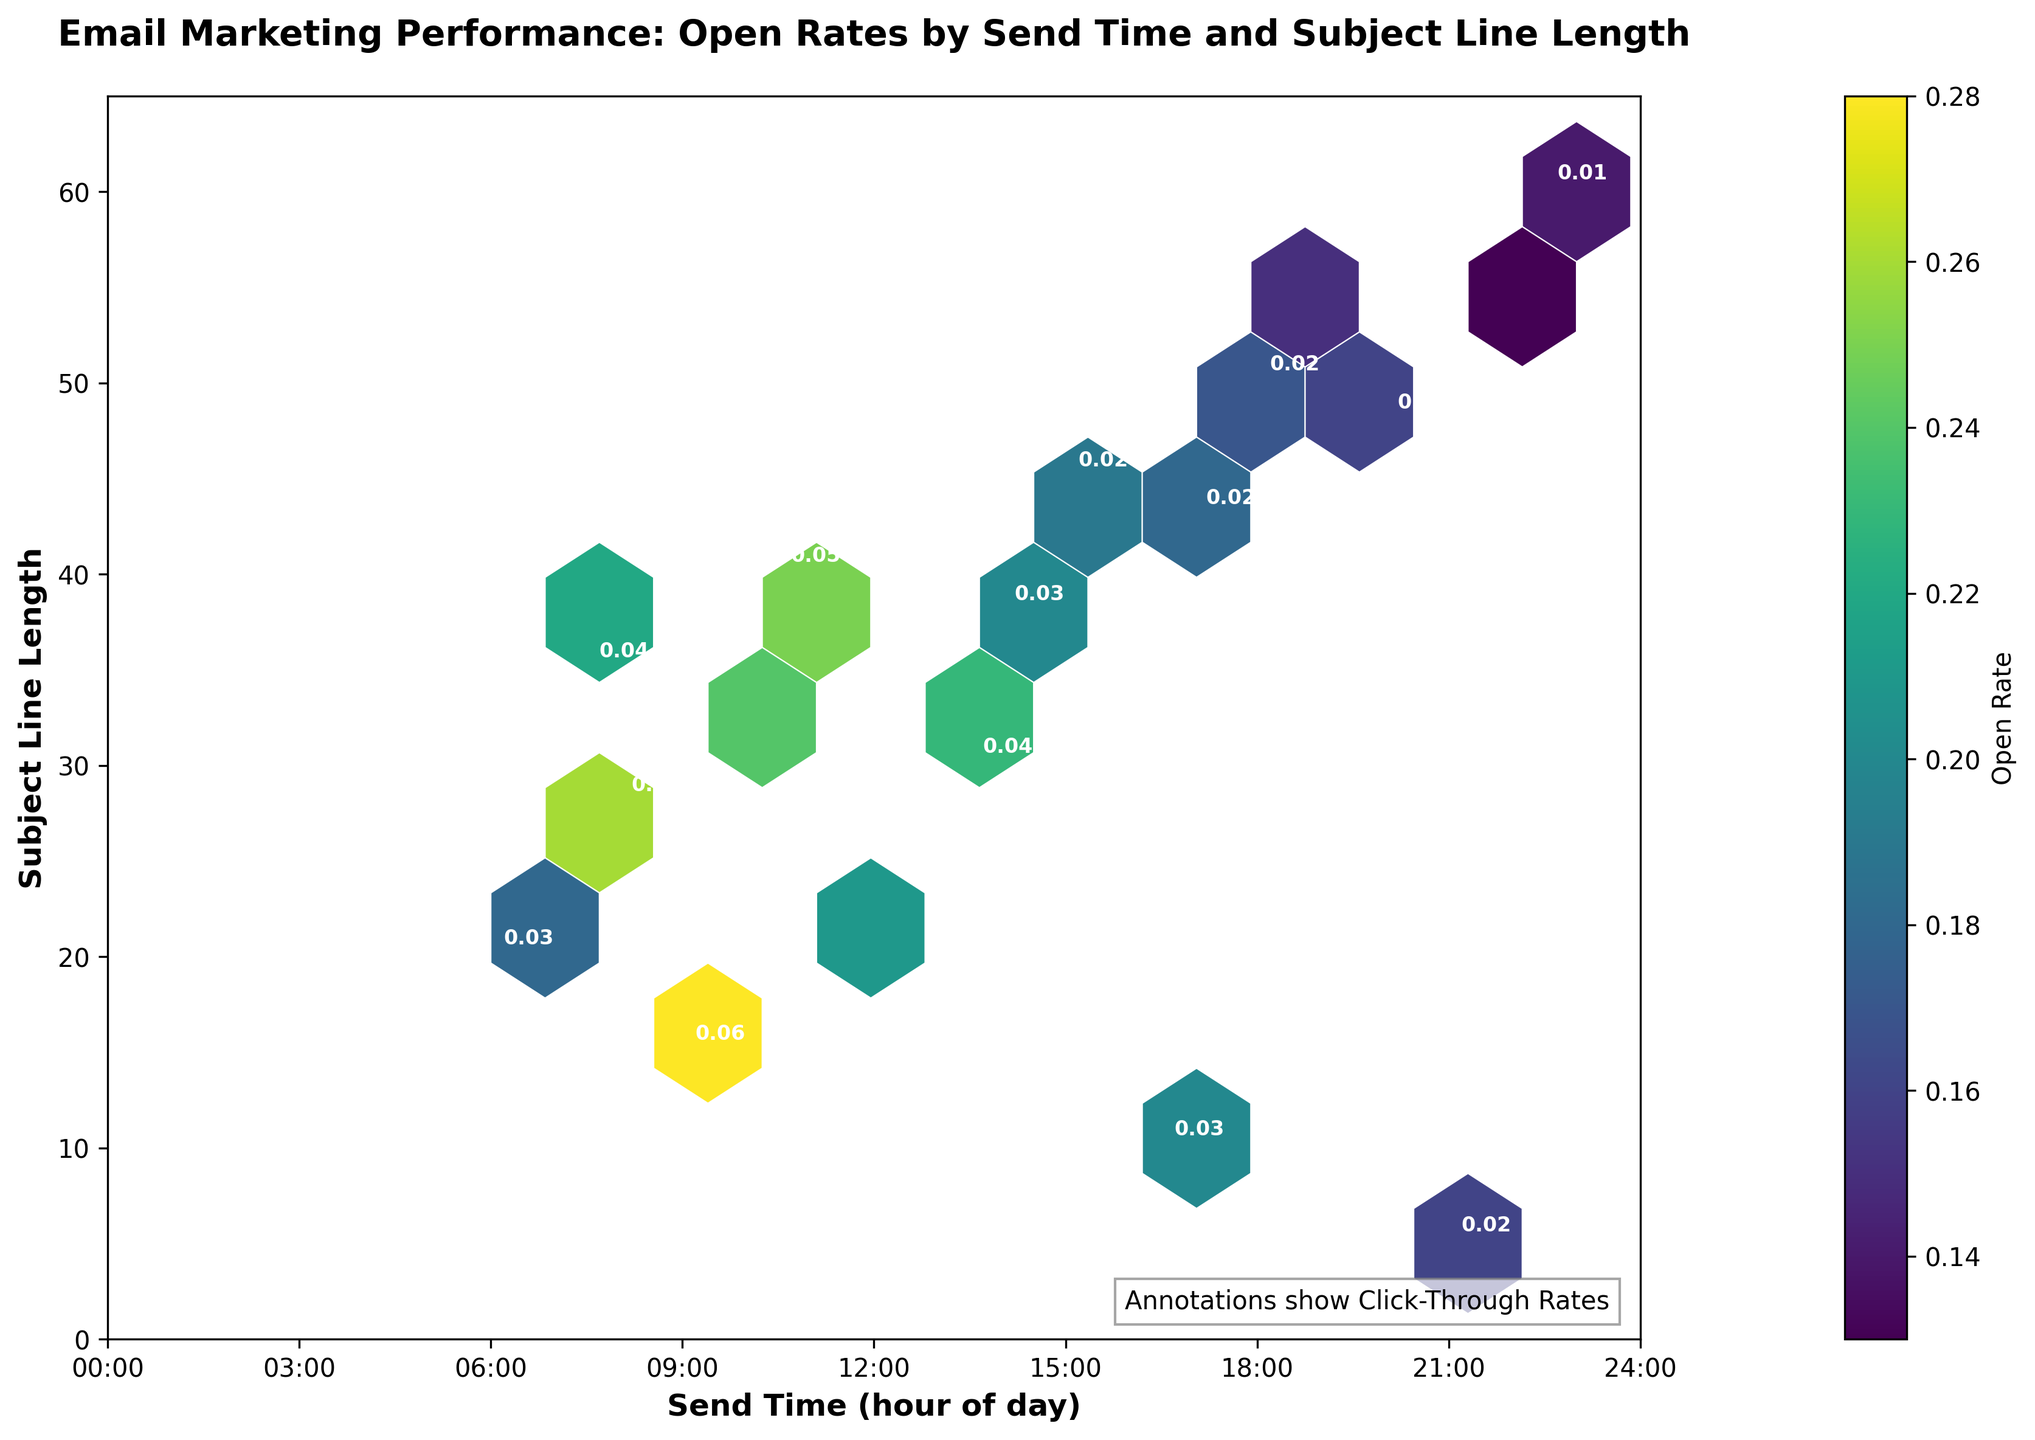What is the title of the plot? The title of the plot is clearly displayed at the top of the figure and serves as a descriptive summary of what the visual represents. Here, the title is "Email Marketing Performance: Open Rates by Send Time and Subject Line Length."
Answer: Email Marketing Performance: Open Rates by Send Time and Subject Line Length What do the colors in the hexagons represent? By examining the legend next to the plot, it is evident that the colors in the hexagons correspond to the open rates of the emails.
Answer: Open Rate At what time is the highest open rate observed? By looking at the colors of the hexagons and identifying the darkest (highest open rate), we can see that the highest open rate is observed around the 9:00 time slot.
Answer: 9:00 Which subject line length has the lowest click-through rate? By observing the annotations inside the hexagons, we can identify that the subject line length of 55 and 60 characters, corresponding to the 19:30 and 22:30 time slots, respectively, feature the lowest click-through rate of 0.01.
Answer: 55 and 60 What is the range of send times represented on the x-axis? The range of send times is labeled on the x-axis, starting from 0 (midnight) to 24 (midnight the next day) with tick marks at every 3-hour interval.
Answer: 0 to 24 hours Which subject line length ranges has the highest cluster of high open rates? By focusing on the dense clusters of darker hexagons, the highest cluster of high open rates is observed with subject line lengths ranging from about 15 to 35 characters.
Answer: 15 to 35 characters Does the plot suggest any relationship between send time and subject line length for achieving high open rates? The darkest hexagons (highest open rates) tend to occur in the earlier hours of the day (e.g., 6:00 to 11:00) and with shorter to moderate subject line lengths (e.g., 15 to 35 characters), suggesting that this combination might be favorable for higher open rates.
Answer: Yes, high open rates are generally associated with early morning send times and shorter subject line lengths Compare the open rates between emails sent at 9:00 and 18:00 with similar subject line lengths. Which one is higher? By examining the hexagons at 9:00 and 18:00 for similar subject line lengths (around 15 and 50, respectively), the hexagon at 9:00 with 15 characters is darker indicating a higher open rate compared to the one at 18:00.
Answer: The open rate is higher at 9:00 What does the annotation 'Annotations show Click-Through Rates' indicate? This text at the bottom of the plot informs viewers that the numeric annotations inside each hexagon represent the click-through rates for the corresponding send time and subject line length combinations.
Answer: It indicates that the annotations represent click-through rates Is there any noticeable pattern in the click-through rates based on hexbin colors? By comparing the annotated click-through rates with the hexbin colors, we can see that areas with higher open rates (darker hexagons) do not necessarily correspond with higher click-through rates. Click-through rates appear uniformly low regardless of open rates.
Answer: No, there's no noticeable pattern 